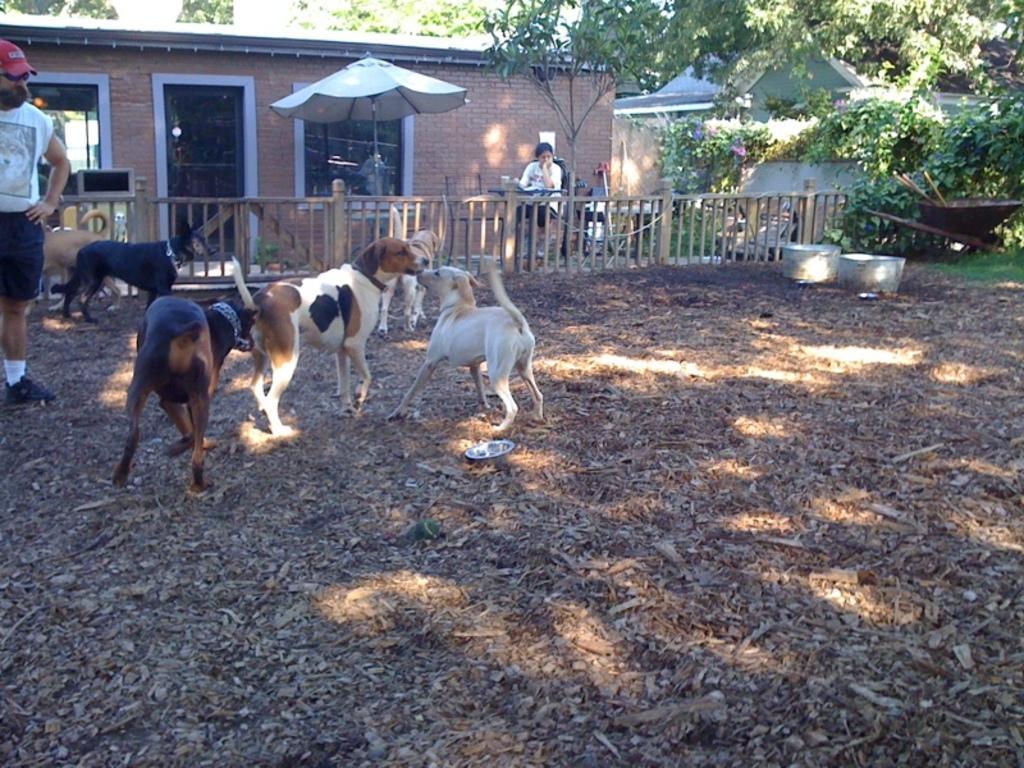In one or two sentences, can you explain what this image depicts? In this picture I can see some dogs are on the ground side one person is standing and watching, we can see a woman is sitting in front of the fencing behind we can see some houses and trees. 